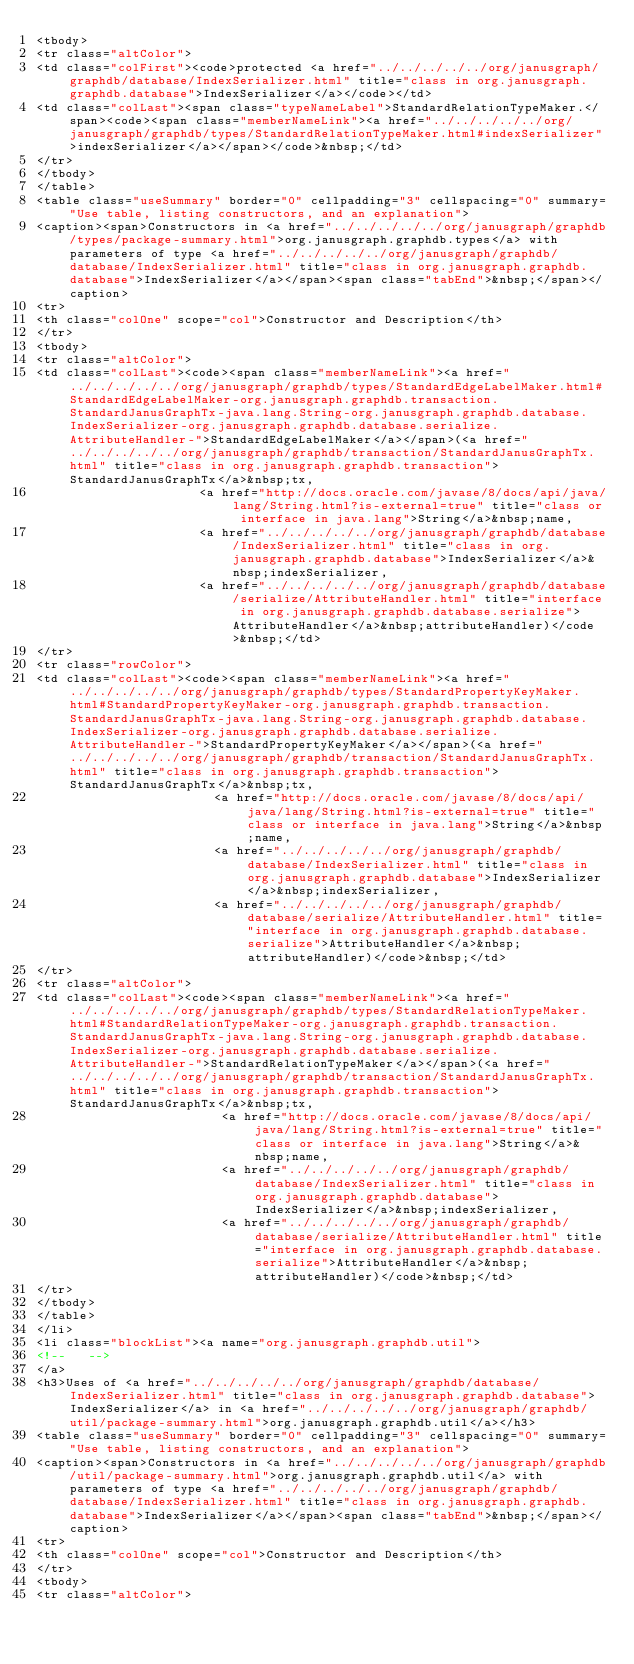Convert code to text. <code><loc_0><loc_0><loc_500><loc_500><_HTML_><tbody>
<tr class="altColor">
<td class="colFirst"><code>protected <a href="../../../../../org/janusgraph/graphdb/database/IndexSerializer.html" title="class in org.janusgraph.graphdb.database">IndexSerializer</a></code></td>
<td class="colLast"><span class="typeNameLabel">StandardRelationTypeMaker.</span><code><span class="memberNameLink"><a href="../../../../../org/janusgraph/graphdb/types/StandardRelationTypeMaker.html#indexSerializer">indexSerializer</a></span></code>&nbsp;</td>
</tr>
</tbody>
</table>
<table class="useSummary" border="0" cellpadding="3" cellspacing="0" summary="Use table, listing constructors, and an explanation">
<caption><span>Constructors in <a href="../../../../../org/janusgraph/graphdb/types/package-summary.html">org.janusgraph.graphdb.types</a> with parameters of type <a href="../../../../../org/janusgraph/graphdb/database/IndexSerializer.html" title="class in org.janusgraph.graphdb.database">IndexSerializer</a></span><span class="tabEnd">&nbsp;</span></caption>
<tr>
<th class="colOne" scope="col">Constructor and Description</th>
</tr>
<tbody>
<tr class="altColor">
<td class="colLast"><code><span class="memberNameLink"><a href="../../../../../org/janusgraph/graphdb/types/StandardEdgeLabelMaker.html#StandardEdgeLabelMaker-org.janusgraph.graphdb.transaction.StandardJanusGraphTx-java.lang.String-org.janusgraph.graphdb.database.IndexSerializer-org.janusgraph.graphdb.database.serialize.AttributeHandler-">StandardEdgeLabelMaker</a></span>(<a href="../../../../../org/janusgraph/graphdb/transaction/StandardJanusGraphTx.html" title="class in org.janusgraph.graphdb.transaction">StandardJanusGraphTx</a>&nbsp;tx,
                      <a href="http://docs.oracle.com/javase/8/docs/api/java/lang/String.html?is-external=true" title="class or interface in java.lang">String</a>&nbsp;name,
                      <a href="../../../../../org/janusgraph/graphdb/database/IndexSerializer.html" title="class in org.janusgraph.graphdb.database">IndexSerializer</a>&nbsp;indexSerializer,
                      <a href="../../../../../org/janusgraph/graphdb/database/serialize/AttributeHandler.html" title="interface in org.janusgraph.graphdb.database.serialize">AttributeHandler</a>&nbsp;attributeHandler)</code>&nbsp;</td>
</tr>
<tr class="rowColor">
<td class="colLast"><code><span class="memberNameLink"><a href="../../../../../org/janusgraph/graphdb/types/StandardPropertyKeyMaker.html#StandardPropertyKeyMaker-org.janusgraph.graphdb.transaction.StandardJanusGraphTx-java.lang.String-org.janusgraph.graphdb.database.IndexSerializer-org.janusgraph.graphdb.database.serialize.AttributeHandler-">StandardPropertyKeyMaker</a></span>(<a href="../../../../../org/janusgraph/graphdb/transaction/StandardJanusGraphTx.html" title="class in org.janusgraph.graphdb.transaction">StandardJanusGraphTx</a>&nbsp;tx,
                        <a href="http://docs.oracle.com/javase/8/docs/api/java/lang/String.html?is-external=true" title="class or interface in java.lang">String</a>&nbsp;name,
                        <a href="../../../../../org/janusgraph/graphdb/database/IndexSerializer.html" title="class in org.janusgraph.graphdb.database">IndexSerializer</a>&nbsp;indexSerializer,
                        <a href="../../../../../org/janusgraph/graphdb/database/serialize/AttributeHandler.html" title="interface in org.janusgraph.graphdb.database.serialize">AttributeHandler</a>&nbsp;attributeHandler)</code>&nbsp;</td>
</tr>
<tr class="altColor">
<td class="colLast"><code><span class="memberNameLink"><a href="../../../../../org/janusgraph/graphdb/types/StandardRelationTypeMaker.html#StandardRelationTypeMaker-org.janusgraph.graphdb.transaction.StandardJanusGraphTx-java.lang.String-org.janusgraph.graphdb.database.IndexSerializer-org.janusgraph.graphdb.database.serialize.AttributeHandler-">StandardRelationTypeMaker</a></span>(<a href="../../../../../org/janusgraph/graphdb/transaction/StandardJanusGraphTx.html" title="class in org.janusgraph.graphdb.transaction">StandardJanusGraphTx</a>&nbsp;tx,
                         <a href="http://docs.oracle.com/javase/8/docs/api/java/lang/String.html?is-external=true" title="class or interface in java.lang">String</a>&nbsp;name,
                         <a href="../../../../../org/janusgraph/graphdb/database/IndexSerializer.html" title="class in org.janusgraph.graphdb.database">IndexSerializer</a>&nbsp;indexSerializer,
                         <a href="../../../../../org/janusgraph/graphdb/database/serialize/AttributeHandler.html" title="interface in org.janusgraph.graphdb.database.serialize">AttributeHandler</a>&nbsp;attributeHandler)</code>&nbsp;</td>
</tr>
</tbody>
</table>
</li>
<li class="blockList"><a name="org.janusgraph.graphdb.util">
<!--   -->
</a>
<h3>Uses of <a href="../../../../../org/janusgraph/graphdb/database/IndexSerializer.html" title="class in org.janusgraph.graphdb.database">IndexSerializer</a> in <a href="../../../../../org/janusgraph/graphdb/util/package-summary.html">org.janusgraph.graphdb.util</a></h3>
<table class="useSummary" border="0" cellpadding="3" cellspacing="0" summary="Use table, listing constructors, and an explanation">
<caption><span>Constructors in <a href="../../../../../org/janusgraph/graphdb/util/package-summary.html">org.janusgraph.graphdb.util</a> with parameters of type <a href="../../../../../org/janusgraph/graphdb/database/IndexSerializer.html" title="class in org.janusgraph.graphdb.database">IndexSerializer</a></span><span class="tabEnd">&nbsp;</span></caption>
<tr>
<th class="colOne" scope="col">Constructor and Description</th>
</tr>
<tbody>
<tr class="altColor"></code> 